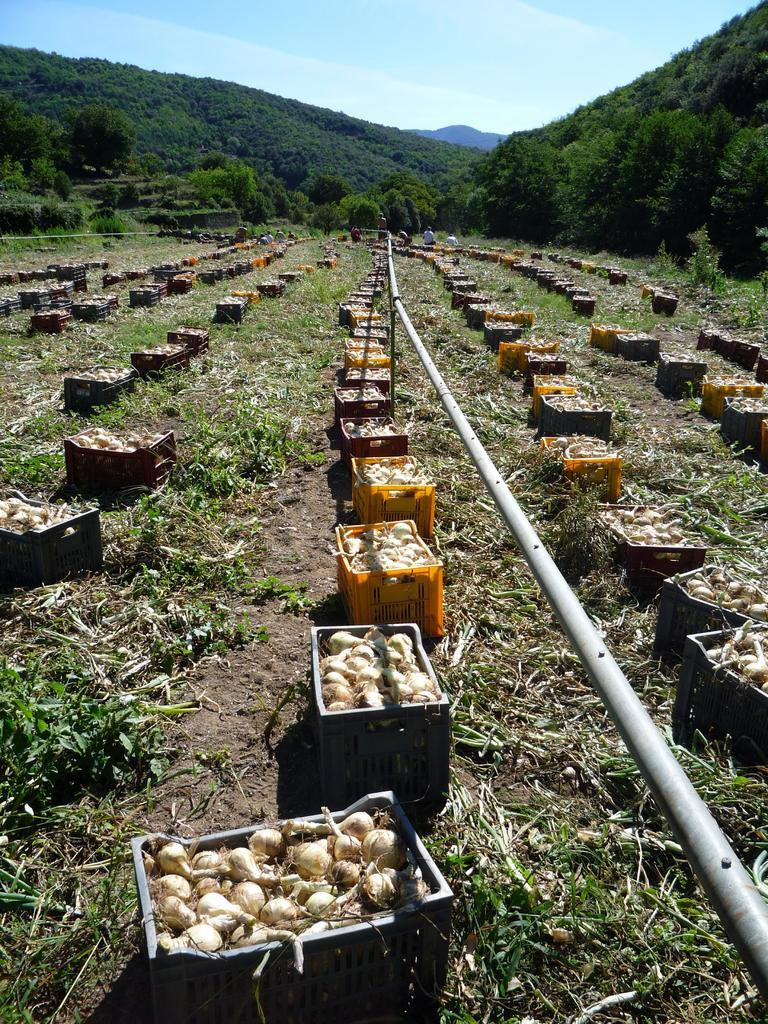What is the setting of the image? The image shows an outside view. What can be found in the baskets in the image? There are baskets containing onions in the image. What is the object in the middle of the image? There is a pipe in the middle of the image. What geographical feature is visible in the image? There is a hill visible in the image. What is visible at the top of the image? The sky is visible at the top of the image. What type of question is being asked by the police officer in the image? There are no police officers or questions being asked in the image. 